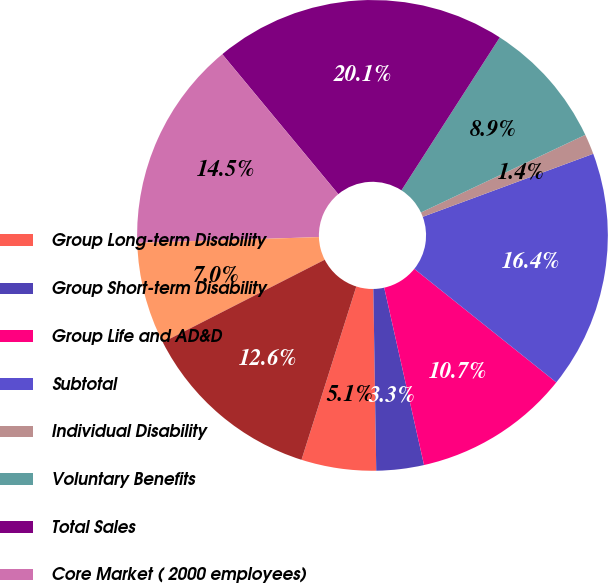<chart> <loc_0><loc_0><loc_500><loc_500><pie_chart><fcel>Group Long-term Disability<fcel>Group Short-term Disability<fcel>Group Life and AD&D<fcel>Subtotal<fcel>Individual Disability<fcel>Voluntary Benefits<fcel>Total Sales<fcel>Core Market ( 2000 employees)<fcel>Large Case Market<fcel>Supplemental and Voluntary<nl><fcel>5.13%<fcel>3.26%<fcel>10.75%<fcel>16.37%<fcel>1.39%<fcel>8.88%<fcel>20.11%<fcel>14.49%<fcel>7.0%<fcel>12.62%<nl></chart> 